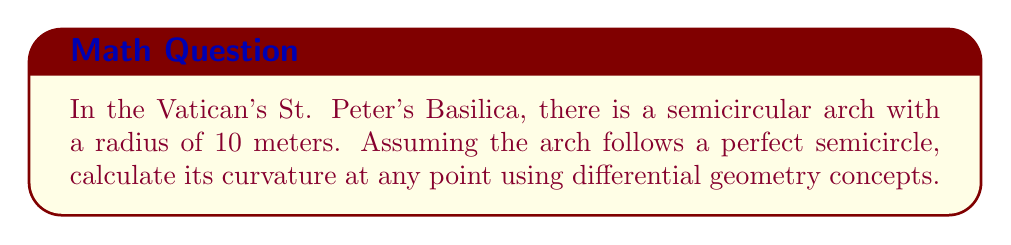Teach me how to tackle this problem. Let's approach this step-by-step:

1) In differential geometry, the curvature of a circle (or circular arc) is constant at all points and is given by the reciprocal of its radius:

   $$ \kappa = \frac{1}{R} $$

   where $\kappa$ is the curvature and $R$ is the radius.

2) For a semicircular arch, we can parametrize it as:

   $$ x(t) = R \cos(t) $$
   $$ y(t) = R \sin(t) $$

   where $0 \leq t \leq \pi$ for a semicircle, and $R$ is the radius.

3) The curvature can also be calculated using the formula:

   $$ \kappa = \frac{|x'y'' - y'x''|}{(x'^2 + y'^2)^{3/2}} $$

4) Let's verify this matches our simple formula. First, we calculate the derivatives:

   $$ x'(t) = -R \sin(t) $$
   $$ y'(t) = R \cos(t) $$
   $$ x''(t) = -R \cos(t) $$
   $$ y''(t) = -R \sin(t) $$

5) Substituting these into our curvature formula:

   $$ \kappa = \frac{|(-R\sin(t))(-R\sin(t)) - (R\cos(t))(-R\cos(t))|}{((-R\sin(t))^2 + (R\cos(t))^2)^{3/2}} $$

6) Simplifying:

   $$ \kappa = \frac{|R^2\sin^2(t) + R^2\cos^2(t)|}{R^3(\sin^2(t) + \cos^2(t))^{3/2}} = \frac{R^2}{R^3} = \frac{1}{R} $$

7) This confirms that our simple formula $\kappa = \frac{1}{R}$ is correct.

8) For the arch in St. Peter's Basilica with a radius of 10 meters:

   $$ \kappa = \frac{1}{R} = \frac{1}{10} = 0.1 \text{ m}^{-1} $$
Answer: $0.1 \text{ m}^{-1}$ 